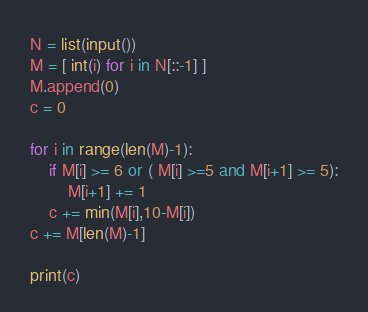<code> <loc_0><loc_0><loc_500><loc_500><_Python_>N = list(input())
M = [ int(i) for i in N[::-1] ]
M.append(0)
c = 0

for i in range(len(M)-1):
    if M[i] >= 6 or ( M[i] >=5 and M[i+1] >= 5):
        M[i+1] += 1
    c += min(M[i],10-M[i])
c += M[len(M)-1]

print(c)</code> 